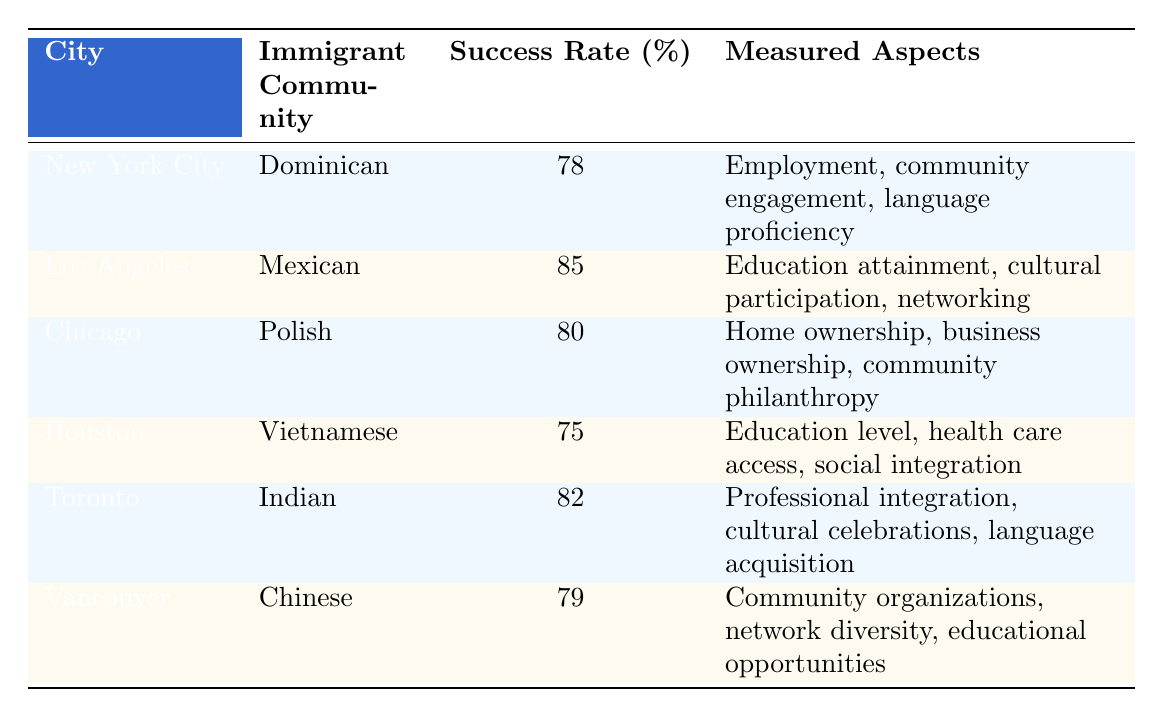What is the success rate percentage of the Mexican immigrant community in Los Angeles? The table shows that the success rate percentage for the Mexican immigrant community in Los Angeles is directly listed as 85.
Answer: 85 Which city has the lowest success rate percentage among the communities listed? By comparing the success rates of each city, Houston has the lowest success rate percentage at 75.
Answer: 75 What are the three measured aspects of cultural integration for the Dominican community in New York City? The table specifies that for the Dominican community in New York City, the measured aspects are employment, community engagement, and language proficiency.
Answer: Employment, community engagement, language proficiency Is the success rate of the Polish community in Chicago higher than that of the Vietnamese community in Houston? The success rate of the Polish community is 80%, while the Vietnamese community's rate is 75%. Since 80 is greater than 75, the statement is true.
Answer: Yes What is the average success rate percentage of the immigrant communities listed in Toronto and Vancouver? The success rates for Toronto and Vancouver are 82% and 79%, respectively. To find the average, add the two rates (82 + 79 = 161), and divide by 2 to get the average (161 / 2 = 80.5).
Answer: 80.5 Which immigrant community has a success rate above 80% and what is their primary measured aspect? Both the Mexican community in Los Angeles (85%) and the Indian community in Toronto (82%) have success rates above 80%. The primary measured aspect for the Mexican community is education attainment, while for the Indian community it is professional integration.
Answer: Mexican: Education attainment, Indian: Professional integration Is cultural participation one of the measured aspects for the Vietnamese community? Referring to the table, the measured aspects for the Vietnamese community in Houston are education level, health care access, and social integration. Cultural participation is not included among these aspects.
Answer: No What is the difference in success rate percentage between the Dominican community in New York City and the Indian community in Toronto? The Dominican community has a success rate of 78%, and the Indian community has 82%. The difference is found by subtracting the two rates (82 - 78 = 4).
Answer: 4 